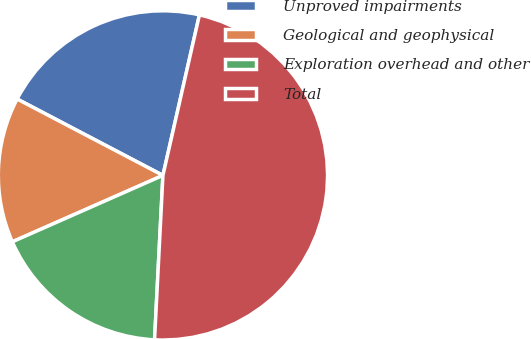Convert chart. <chart><loc_0><loc_0><loc_500><loc_500><pie_chart><fcel>Unproved impairments<fcel>Geological and geophysical<fcel>Exploration overhead and other<fcel>Total<nl><fcel>20.88%<fcel>14.29%<fcel>17.58%<fcel>47.25%<nl></chart> 